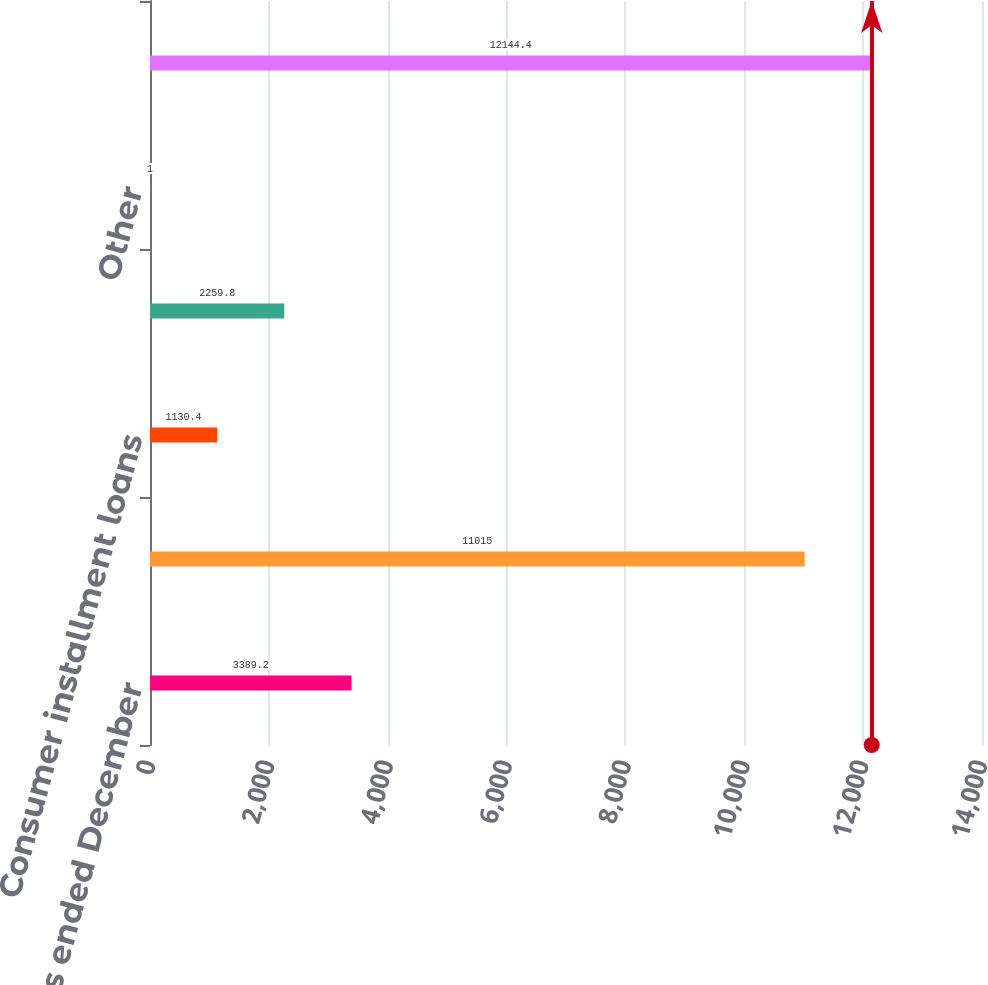Convert chart. <chart><loc_0><loc_0><loc_500><loc_500><bar_chart><fcel>For the years ended December<fcel>Credit cards<fcel>Consumer installment loans<fcel>Commercial credit products<fcel>Other<fcel>Total<nl><fcel>3389.2<fcel>11015<fcel>1130.4<fcel>2259.8<fcel>1<fcel>12144.4<nl></chart> 